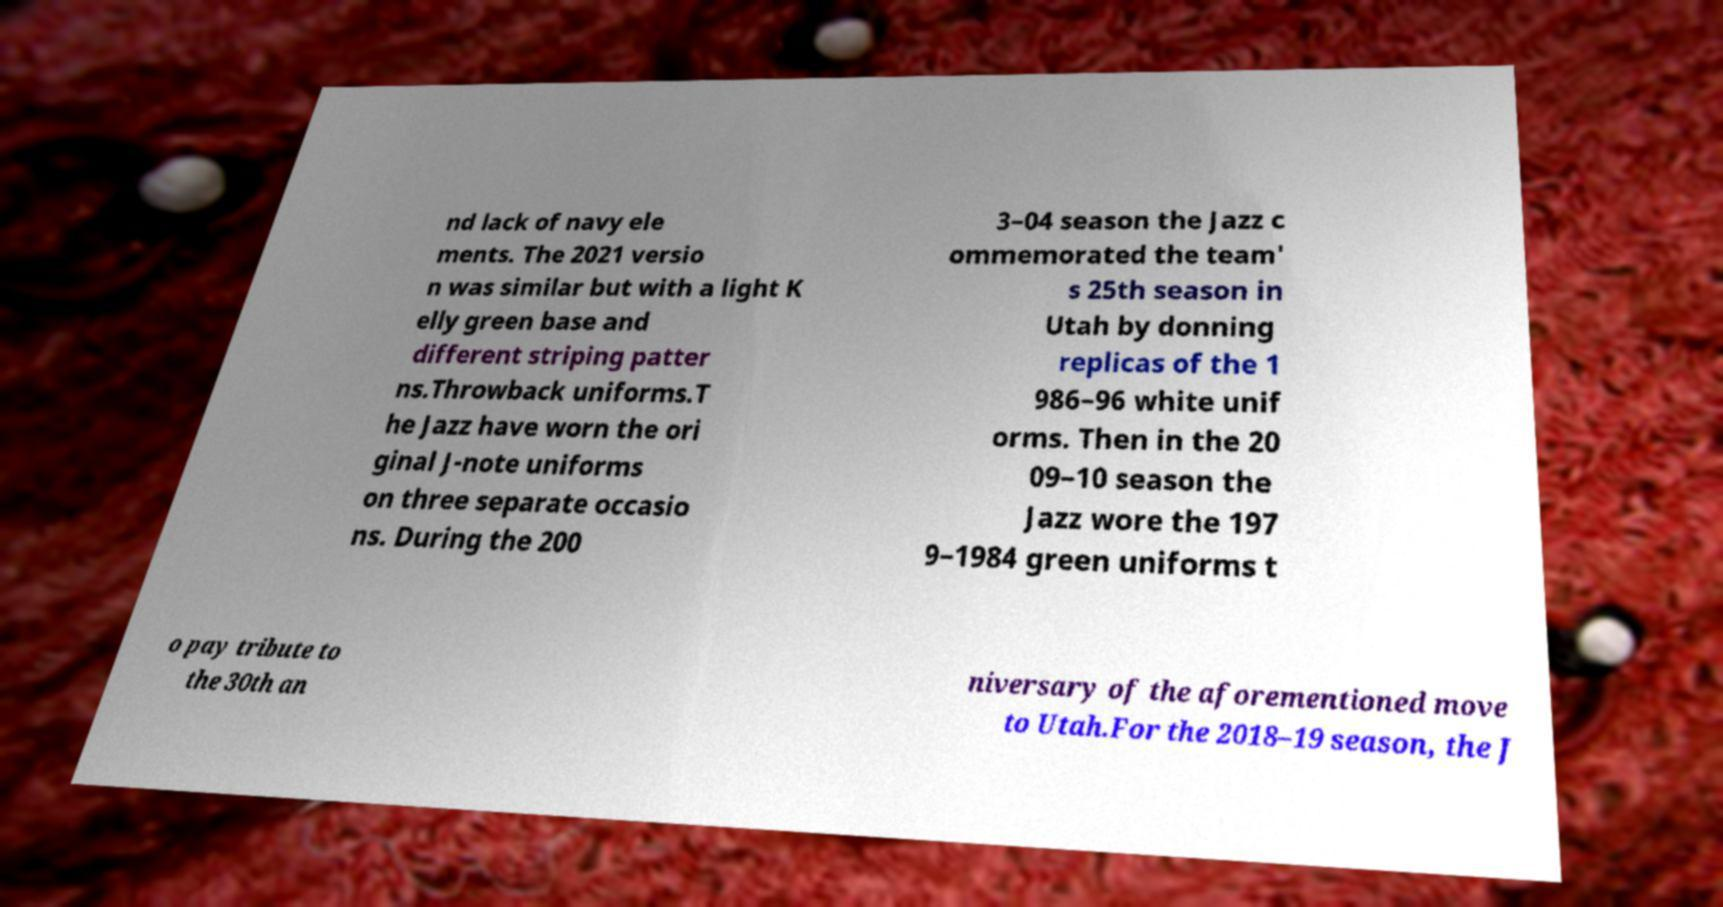Please identify and transcribe the text found in this image. nd lack of navy ele ments. The 2021 versio n was similar but with a light K elly green base and different striping patter ns.Throwback uniforms.T he Jazz have worn the ori ginal J-note uniforms on three separate occasio ns. During the 200 3–04 season the Jazz c ommemorated the team' s 25th season in Utah by donning replicas of the 1 986–96 white unif orms. Then in the 20 09–10 season the Jazz wore the 197 9–1984 green uniforms t o pay tribute to the 30th an niversary of the aforementioned move to Utah.For the 2018–19 season, the J 